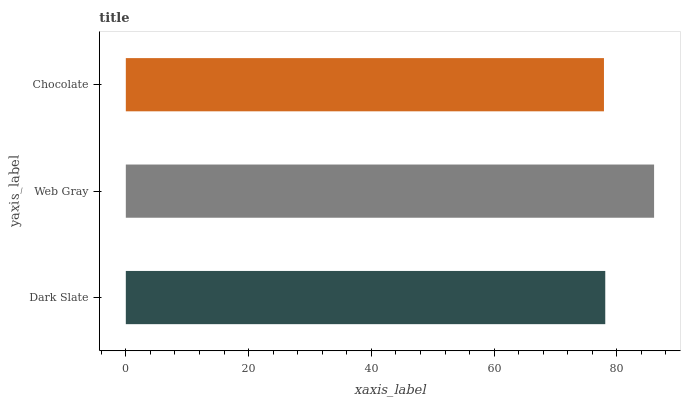Is Chocolate the minimum?
Answer yes or no. Yes. Is Web Gray the maximum?
Answer yes or no. Yes. Is Web Gray the minimum?
Answer yes or no. No. Is Chocolate the maximum?
Answer yes or no. No. Is Web Gray greater than Chocolate?
Answer yes or no. Yes. Is Chocolate less than Web Gray?
Answer yes or no. Yes. Is Chocolate greater than Web Gray?
Answer yes or no. No. Is Web Gray less than Chocolate?
Answer yes or no. No. Is Dark Slate the high median?
Answer yes or no. Yes. Is Dark Slate the low median?
Answer yes or no. Yes. Is Web Gray the high median?
Answer yes or no. No. Is Web Gray the low median?
Answer yes or no. No. 